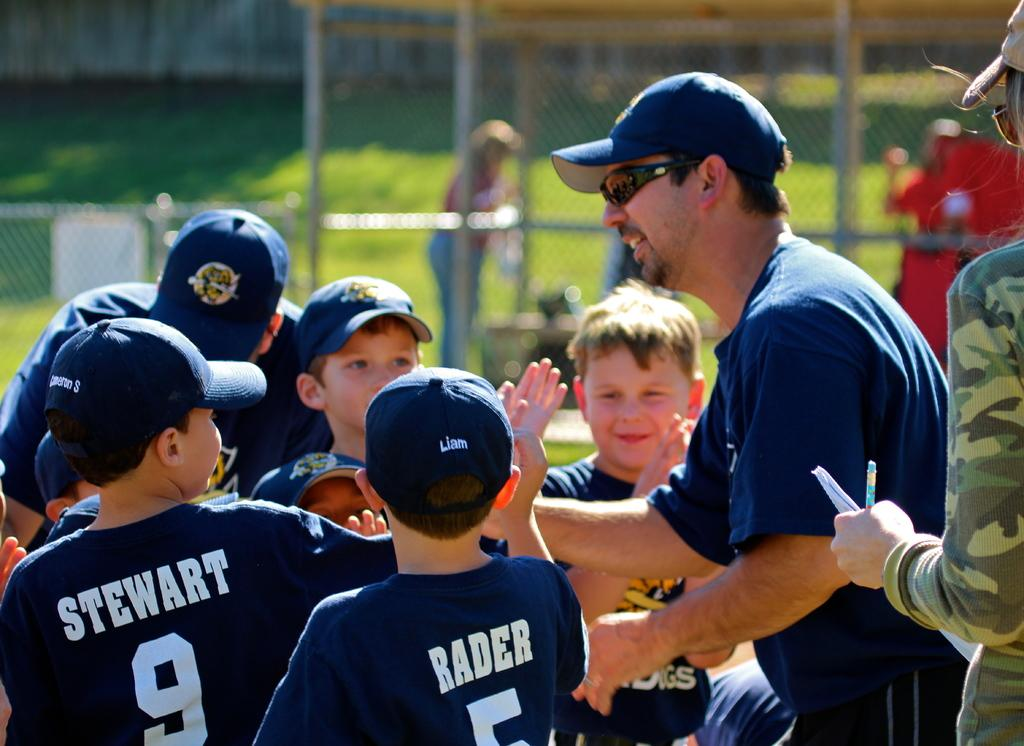Provide a one-sentence caption for the provided image. The coach is congratulating the team, including Stewart and Rader. 